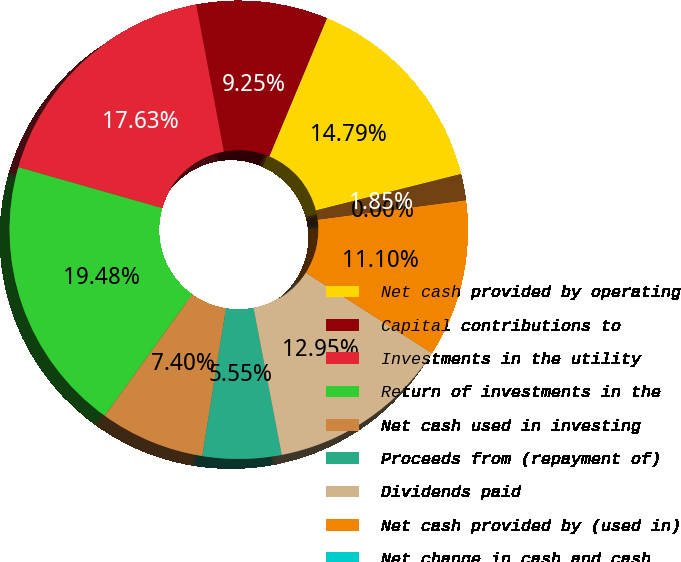<chart> <loc_0><loc_0><loc_500><loc_500><pie_chart><fcel>Net cash provided by operating<fcel>Capital contributions to<fcel>Investments in the utility<fcel>Return of investments in the<fcel>Net cash used in investing<fcel>Proceeds from (repayment of)<fcel>Dividends paid<fcel>Net cash provided by (used in)<fcel>Net change in cash and cash<fcel>Cash and cash equivalents at<nl><fcel>14.79%<fcel>9.25%<fcel>17.63%<fcel>19.48%<fcel>7.4%<fcel>5.55%<fcel>12.95%<fcel>11.1%<fcel>0.0%<fcel>1.85%<nl></chart> 